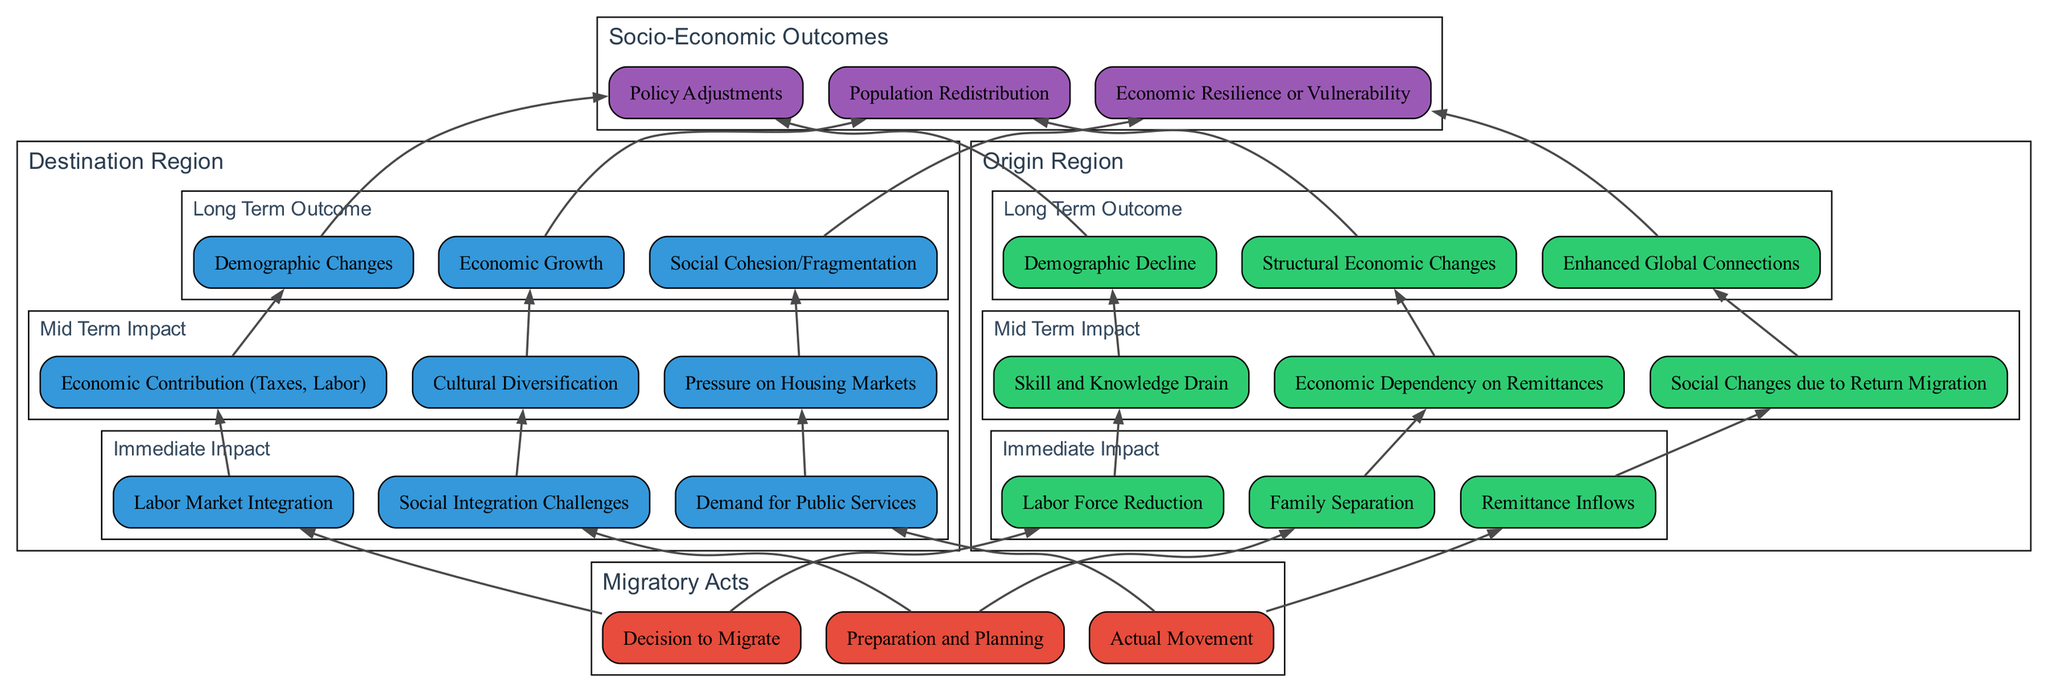What is the first migratory act listed? The diagram begins with three migratory acts, and the first one is labeled as "Decision to Migrate." This is directly observed in the "Migratory Acts" section at the bottom of the diagram.
Answer: Decision to Migrate What are the immediate impacts on the destination region? The "Immediate Impact" section under the "Destination Region" lists three specific outcomes, which are "Labor Market Integration," "Social Integration Challenges," and "Demand for Public Services." These are located in the designated subgraphs for impacts.
Answer: Labor Market Integration, Social Integration Challenges, Demand for Public Services How many long-term outcomes are there for the origin region? In the "Long Term Outcome" section of the "Origin Region," there are three distinct outcomes listed: "Demographic Decline," "Structural Economic Changes," and "Enhanced Global Connections." Counted directly, there are three outcomes.
Answer: 3 Which impacts on the origin region result from actual migratory acts? From the diagram, the actual migratory acts lead to "Labor Force Reduction," "Family Separation," and "Remittance Inflows" as immediate impacts. This relationship is illustrated by the edges connecting the migratory acts to each immediate impact.
Answer: Labor Force Reduction, Family Separation, Remittance Inflows What is the connection between mid-term impacts and long-term outcomes in the destination region? The mid-term impacts, such as "Economic Contribution (Taxes, Labor)," lead to long-term outcomes, such as "Economic Growth." Each mid-term impact connects to a corresponding long-term outcome through directed edges in the diagram, indicating a progression from one to the other.
Answer: Economic Contribution leads to Economic Growth What is one of the total effects listed in the socio-economic outcomes? In the "Socio-Economic Outcomes" section, the total effects include "Policy Adjustments," "Population Redistribution," and "Economic Resilience or Vulnerability." These are directly noted in the final section of the flow chart, signifying the overall effects of migration.
Answer: Policy Adjustments What is the relationship between immediate impacts for both origin and destination regions? The immediate impacts for both regions occur simultaneously from the same migratory acts and are related through the edges that connect them in the diagram. Thus, they reflect direct effects that migrate from the similar initial actions.
Answer: Simultaneous relationship How many total impacts are there in the mid-term section for both regions? Each region has three mid-term impacts listed. Thus the total number of mid-term impacts in both sections combined would be six (3 from the origin region and 3 from the destination region).
Answer: 6 